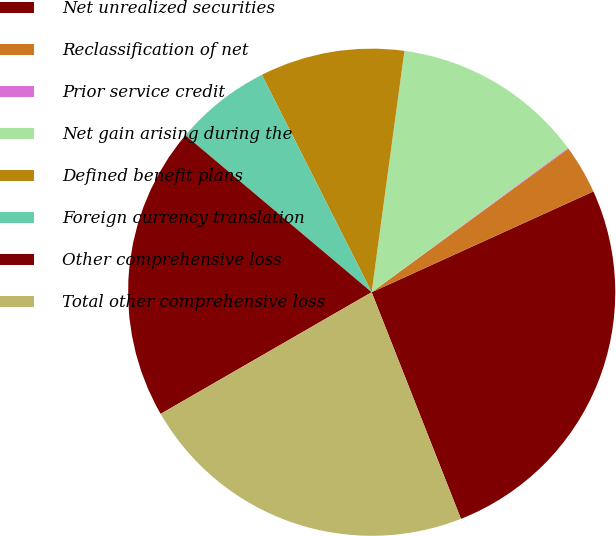<chart> <loc_0><loc_0><loc_500><loc_500><pie_chart><fcel>Net unrealized securities<fcel>Reclassification of net<fcel>Prior service credit<fcel>Net gain arising during the<fcel>Defined benefit plans<fcel>Foreign currency translation<fcel>Other comprehensive loss<fcel>Total other comprehensive loss<nl><fcel>25.82%<fcel>3.24%<fcel>0.06%<fcel>12.76%<fcel>9.59%<fcel>6.41%<fcel>19.47%<fcel>22.65%<nl></chart> 